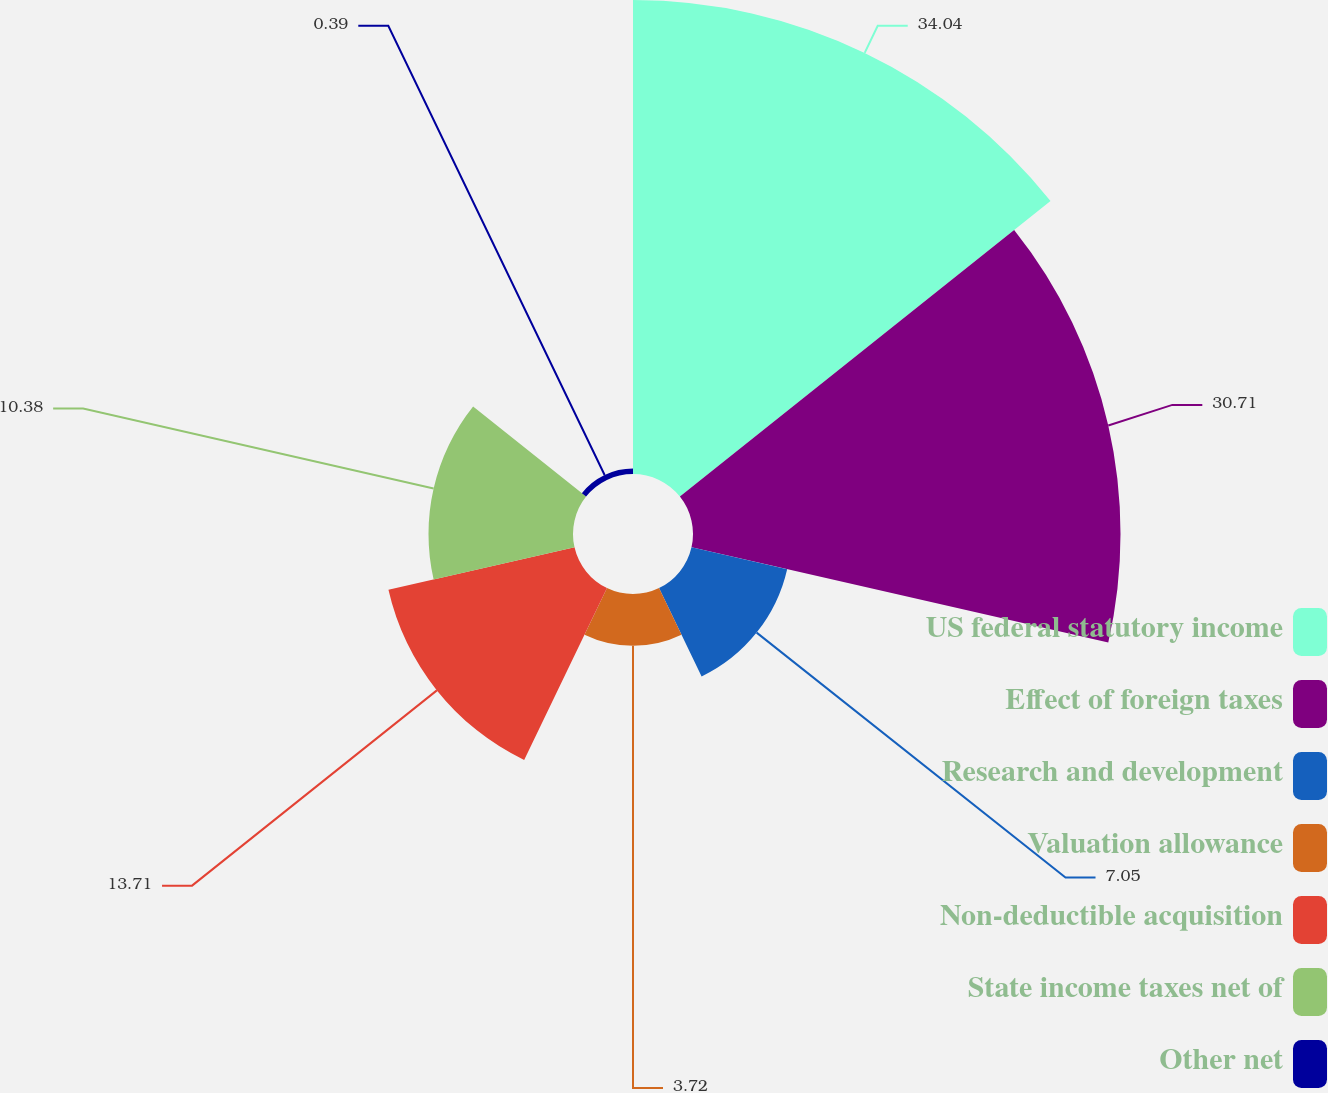<chart> <loc_0><loc_0><loc_500><loc_500><pie_chart><fcel>US federal statutory income<fcel>Effect of foreign taxes<fcel>Research and development<fcel>Valuation allowance<fcel>Non-deductible acquisition<fcel>State income taxes net of<fcel>Other net<nl><fcel>34.05%<fcel>30.71%<fcel>7.05%<fcel>3.72%<fcel>13.71%<fcel>10.38%<fcel>0.39%<nl></chart> 